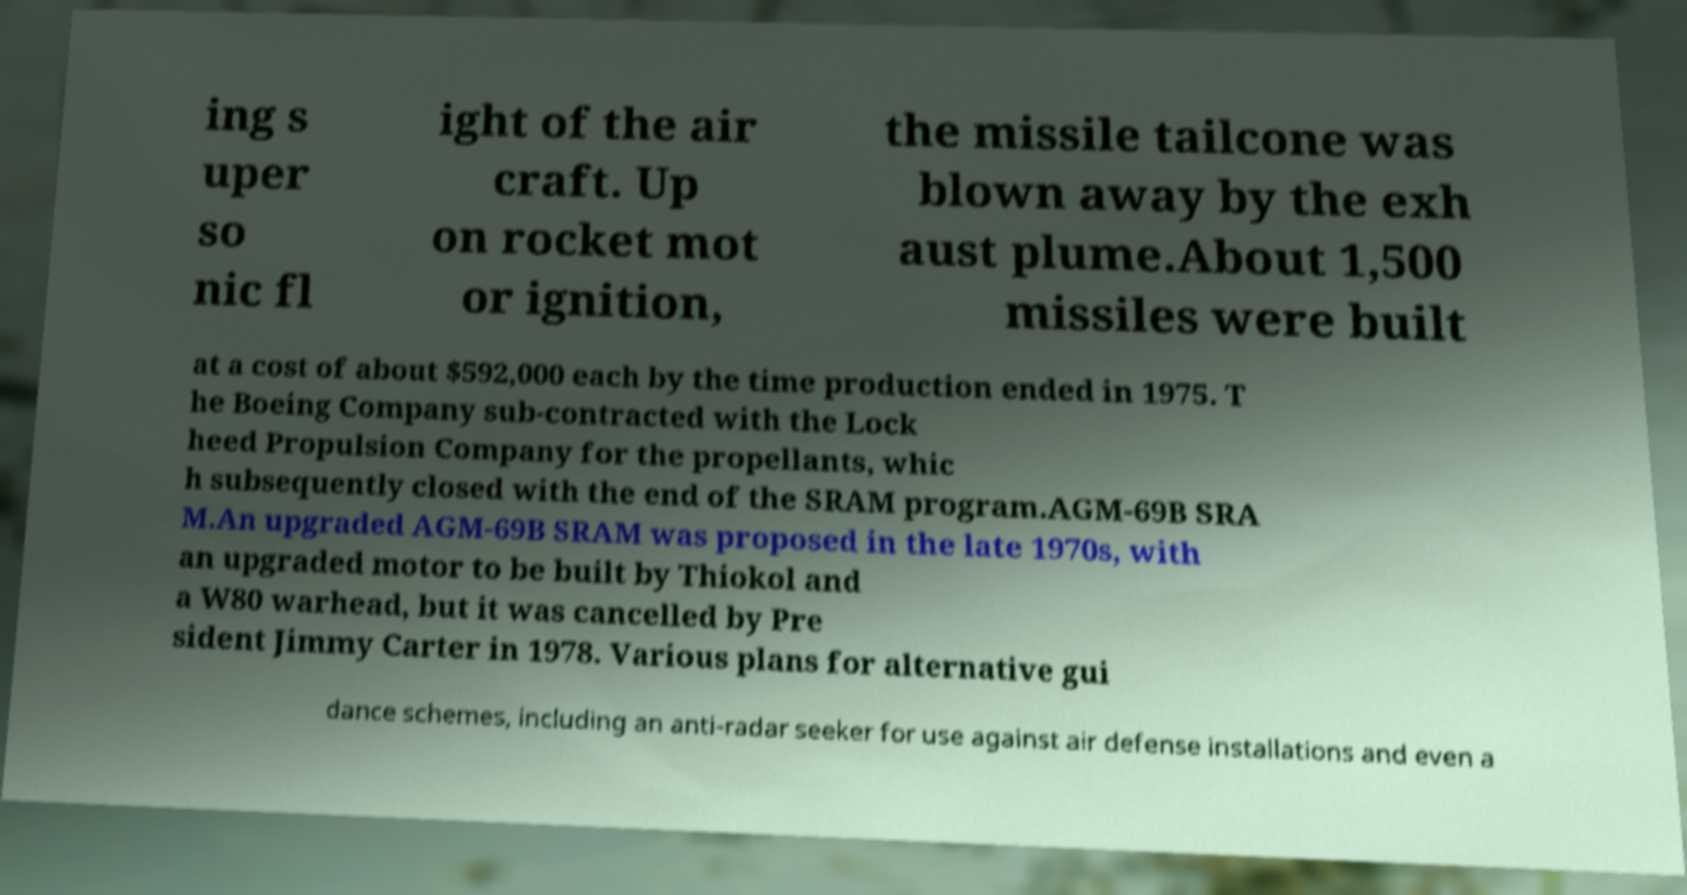Please identify and transcribe the text found in this image. ing s uper so nic fl ight of the air craft. Up on rocket mot or ignition, the missile tailcone was blown away by the exh aust plume.About 1,500 missiles were built at a cost of about $592,000 each by the time production ended in 1975. T he Boeing Company sub-contracted with the Lock heed Propulsion Company for the propellants, whic h subsequently closed with the end of the SRAM program.AGM-69B SRA M.An upgraded AGM-69B SRAM was proposed in the late 1970s, with an upgraded motor to be built by Thiokol and a W80 warhead, but it was cancelled by Pre sident Jimmy Carter in 1978. Various plans for alternative gui dance schemes, including an anti-radar seeker for use against air defense installations and even a 